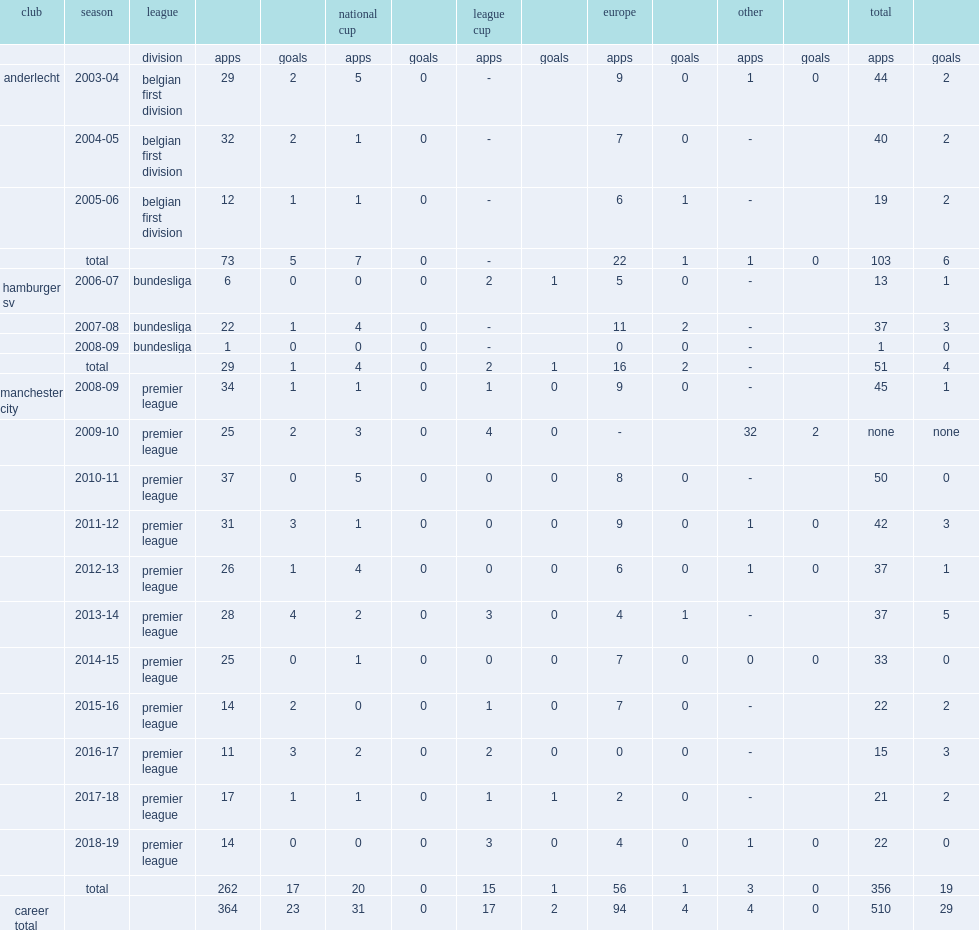Which club did vincent kompany play for in 2011-12? Manchester city. Would you be able to parse every entry in this table? {'header': ['club', 'season', 'league', '', '', 'national cup', '', 'league cup', '', 'europe', '', 'other', '', 'total', ''], 'rows': [['', '', 'division', 'apps', 'goals', 'apps', 'goals', 'apps', 'goals', 'apps', 'goals', 'apps', 'goals', 'apps', 'goals'], ['anderlecht', '2003-04', 'belgian first division', '29', '2', '5', '0', '-', '', '9', '0', '1', '0', '44', '2'], ['', '2004-05', 'belgian first division', '32', '2', '1', '0', '-', '', '7', '0', '-', '', '40', '2'], ['', '2005-06', 'belgian first division', '12', '1', '1', '0', '-', '', '6', '1', '-', '', '19', '2'], ['', 'total', '', '73', '5', '7', '0', '-', '', '22', '1', '1', '0', '103', '6'], ['hamburger sv', '2006-07', 'bundesliga', '6', '0', '0', '0', '2', '1', '5', '0', '-', '', '13', '1'], ['', '2007-08', 'bundesliga', '22', '1', '4', '0', '-', '', '11', '2', '-', '', '37', '3'], ['', '2008-09', 'bundesliga', '1', '0', '0', '0', '-', '', '0', '0', '-', '', '1', '0'], ['', 'total', '', '29', '1', '4', '0', '2', '1', '16', '2', '-', '', '51', '4'], ['manchester city', '2008-09', 'premier league', '34', '1', '1', '0', '1', '0', '9', '0', '-', '', '45', '1'], ['', '2009-10', 'premier league', '25', '2', '3', '0', '4', '0', '-', '', '32', '2', 'none', 'none'], ['', '2010-11', 'premier league', '37', '0', '5', '0', '0', '0', '8', '0', '-', '', '50', '0'], ['', '2011-12', 'premier league', '31', '3', '1', '0', '0', '0', '9', '0', '1', '0', '42', '3'], ['', '2012-13', 'premier league', '26', '1', '4', '0', '0', '0', '6', '0', '1', '0', '37', '1'], ['', '2013-14', 'premier league', '28', '4', '2', '0', '3', '0', '4', '1', '-', '', '37', '5'], ['', '2014-15', 'premier league', '25', '0', '1', '0', '0', '0', '7', '0', '0', '0', '33', '0'], ['', '2015-16', 'premier league', '14', '2', '0', '0', '1', '0', '7', '0', '-', '', '22', '2'], ['', '2016-17', 'premier league', '11', '3', '2', '0', '2', '0', '0', '0', '-', '', '15', '3'], ['', '2017-18', 'premier league', '17', '1', '1', '0', '1', '1', '2', '0', '-', '', '21', '2'], ['', '2018-19', 'premier league', '14', '0', '0', '0', '3', '0', '4', '0', '1', '0', '22', '0'], ['', 'total', '', '262', '17', '20', '0', '15', '1', '56', '1', '3', '0', '356', '19'], ['career total', '', '', '364', '23', '31', '0', '17', '2', '94', '4', '4', '0', '510', '29']]} 